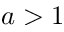Convert formula to latex. <formula><loc_0><loc_0><loc_500><loc_500>a > 1</formula> 